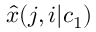Convert formula to latex. <formula><loc_0><loc_0><loc_500><loc_500>{ \widehat { x } } ( j , i | c _ { 1 } )</formula> 